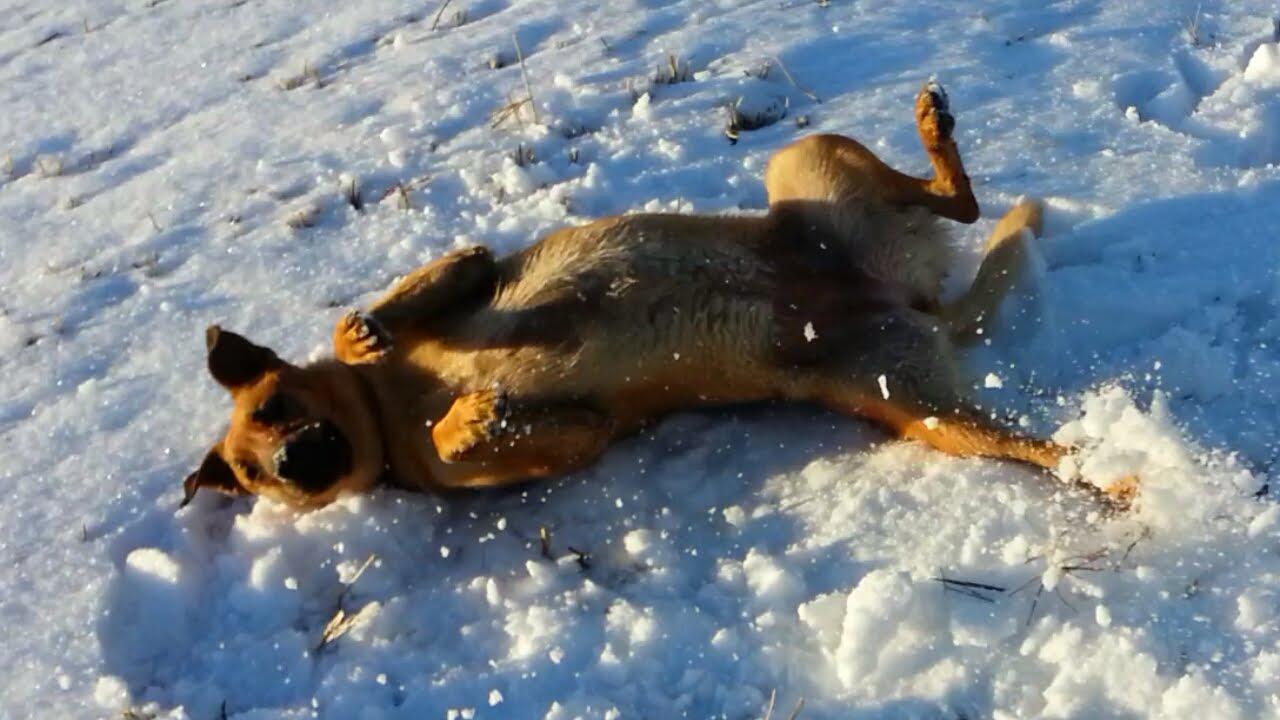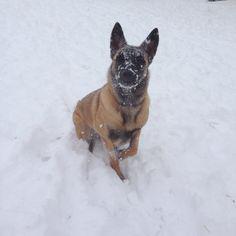The first image is the image on the left, the second image is the image on the right. Assess this claim about the two images: "Right image shows a camera-facing german shepherd dog with snow on its face.". Correct or not? Answer yes or no. Yes. The first image is the image on the left, the second image is the image on the right. For the images shown, is this caption "A single dog is lying down alone in the image on the right." true? Answer yes or no. No. 